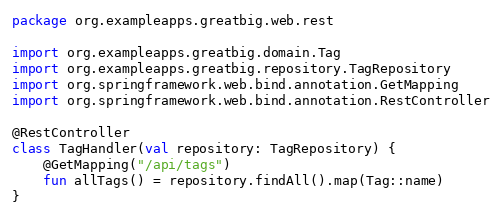Convert code to text. <code><loc_0><loc_0><loc_500><loc_500><_Kotlin_>package org.exampleapps.greatbig.web.rest

import org.exampleapps.greatbig.domain.Tag
import org.exampleapps.greatbig.repository.TagRepository
import org.springframework.web.bind.annotation.GetMapping
import org.springframework.web.bind.annotation.RestController

@RestController
class TagHandler(val repository: TagRepository) {
    @GetMapping("/api/tags")
    fun allTags() = repository.findAll().map(Tag::name)
}
</code> 